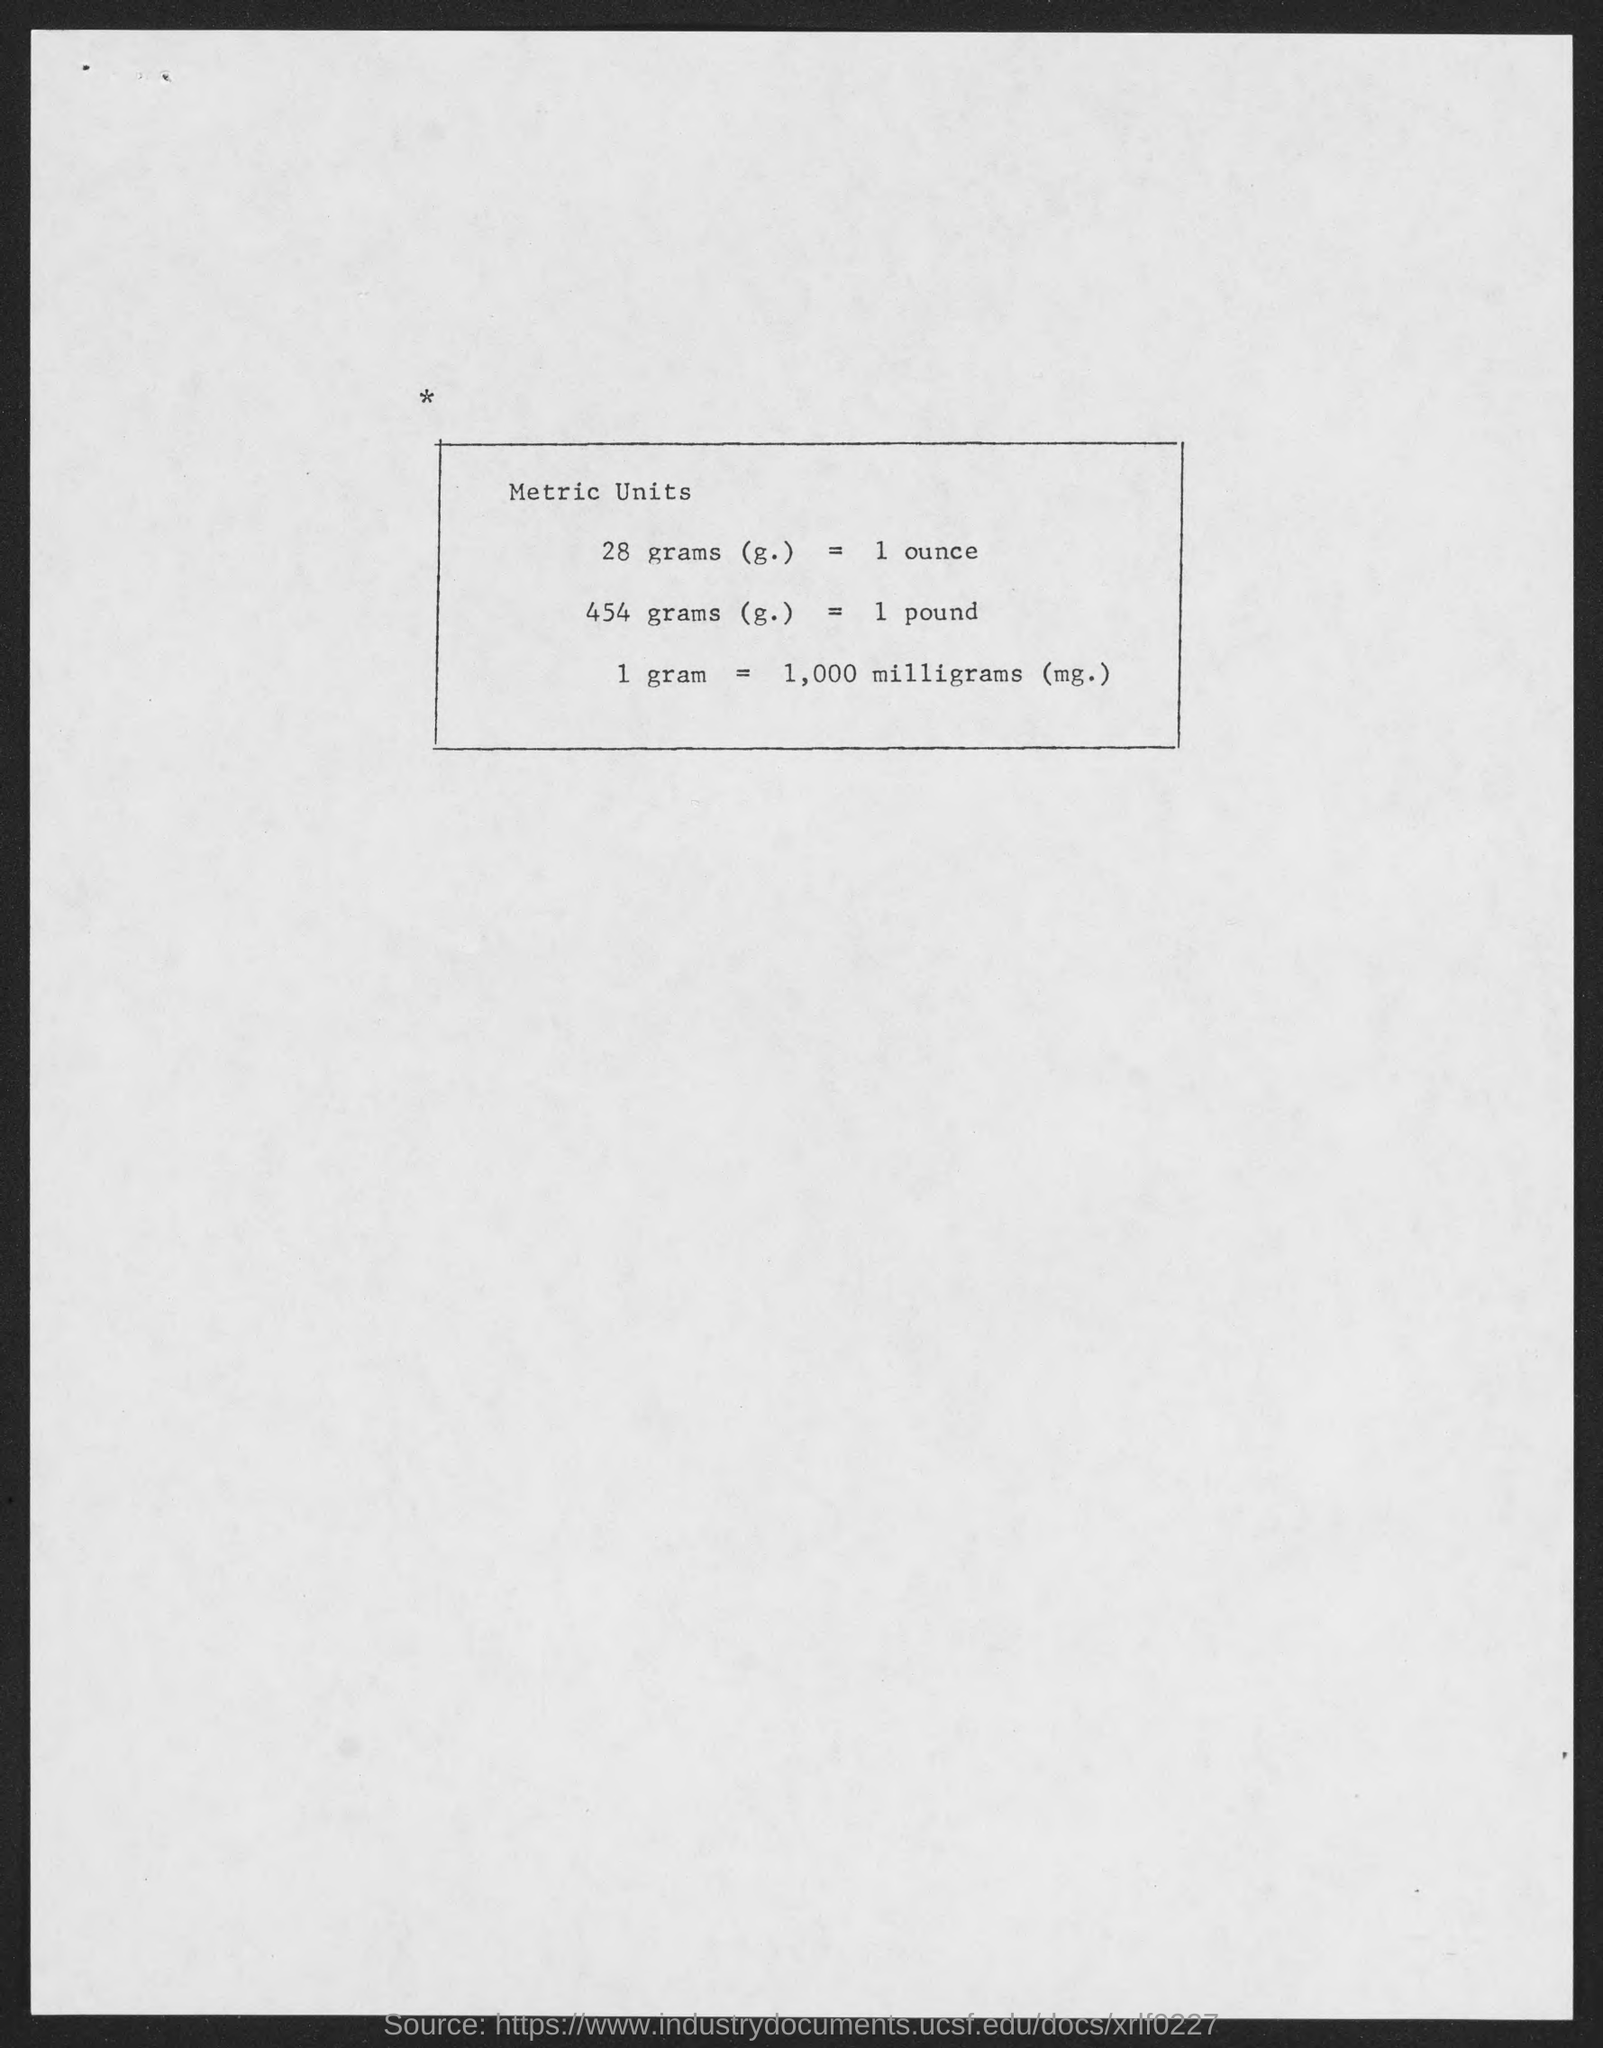Highlight a few significant elements in this photo. In terms of weight measurement, 28 grams is equivalent to 1 ounce. The conversion of 454 grams (g) to 1 pound is equivalent to... 